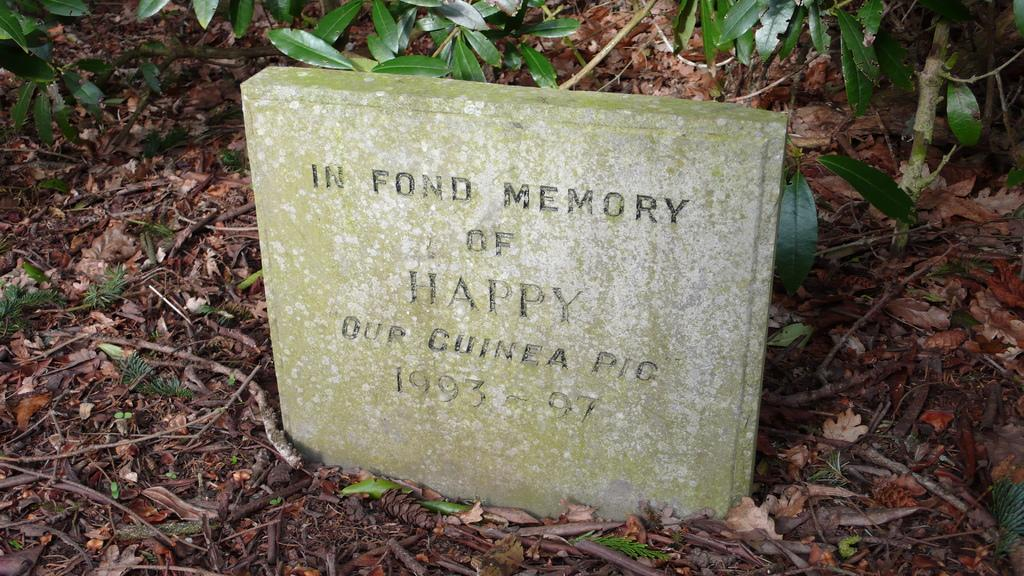What is the main subject in the center of the image? There is a stone in the center of the image. What is written on the stone? Text is written on the stone. What can be seen in the background of the image? There are leaves in the background of the image. What is covering the ground at the bottom of the image? The ground is covered with leaves at the bottom of the image. How does the needle contribute to the image? There is no needle present in the image. 